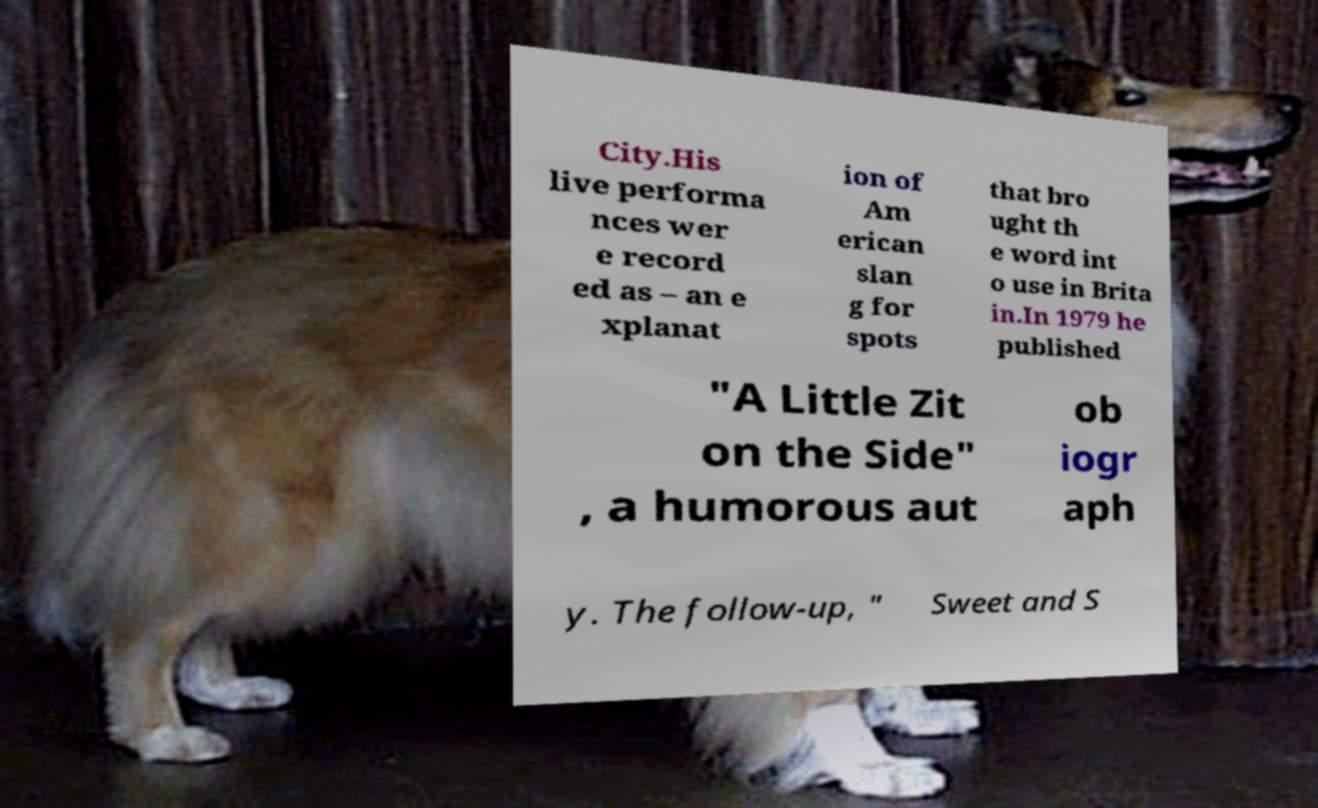Can you accurately transcribe the text from the provided image for me? City.His live performa nces wer e record ed as – an e xplanat ion of Am erican slan g for spots that bro ught th e word int o use in Brita in.In 1979 he published "A Little Zit on the Side" , a humorous aut ob iogr aph y. The follow-up, " Sweet and S 